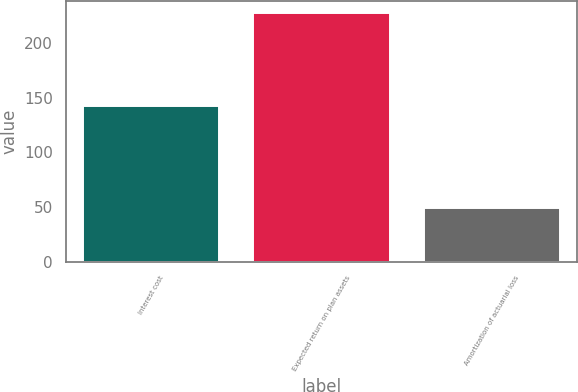<chart> <loc_0><loc_0><loc_500><loc_500><bar_chart><fcel>Interest cost<fcel>Expected return on plan assets<fcel>Amortization of actuarial loss<nl><fcel>142<fcel>227<fcel>49<nl></chart> 